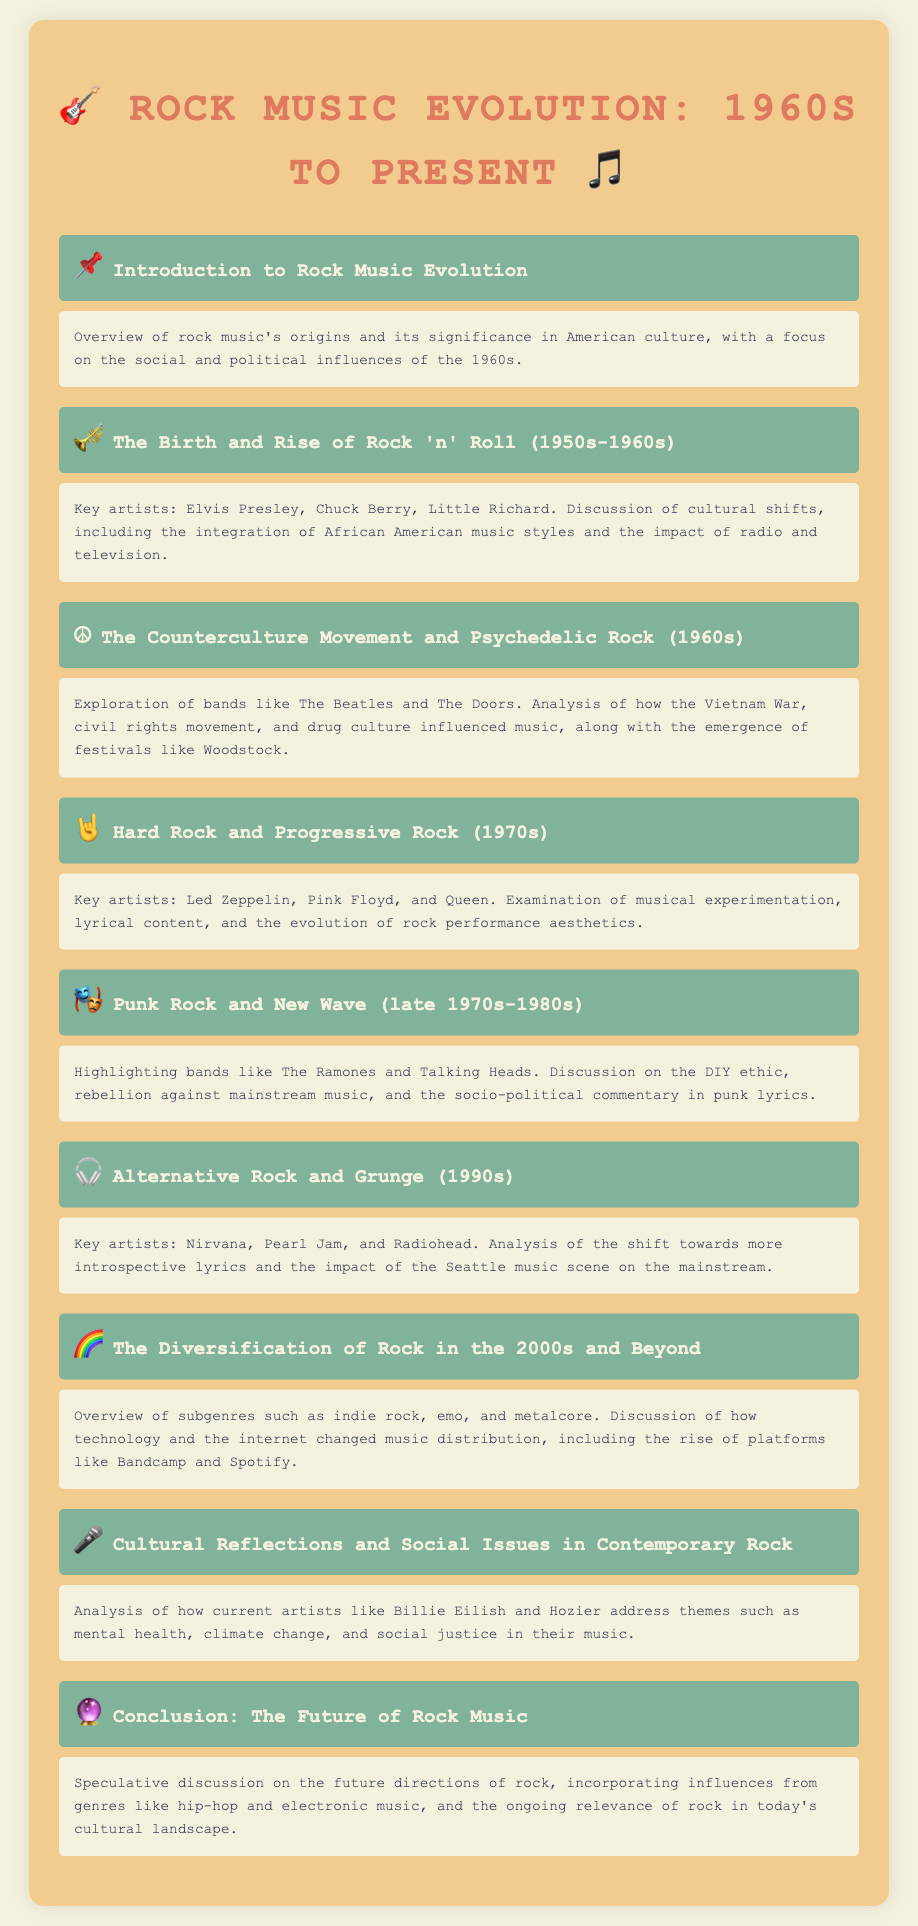what genre influenced the creation of rock music? Rock music was significantly influenced by African American music styles, as mentioned in the document.
Answer: African American music styles who is noted as a key artist in punk rock? The document highlights The Ramones as a key artist during the punk rock era.
Answer: The Ramones what significant cultural event is associated with the 1960s and rock music? The document mentions the Vietnam War as a key cultural event influencing rock music during the 1960s.
Answer: Vietnam War which band is associated with hard rock in the 1970s? Led Zeppelin is noted as a key artist within the hard rock genre in the 1970s.
Answer: Led Zeppelin what change did the Seattle music scene bring in the 1990s? The document states that the Seattle music scene impacted the mainstream leading to more introspective lyrics.
Answer: Introspective lyrics what has changed in music distribution in the 2000s? The document indicates that technology and the internet transformed music distribution, highlighting platforms like Bandcamp and Spotify.
Answer: Bandcamp and Spotify which contemporary artists address social issues in their music? The document mentions Billie Eilish and Hozier as current artists discussing themes like climate change and social justice.
Answer: Billie Eilish and Hozier what was a significant aspect of the cultural shifts during the 1960s? The document discusses the emergence of festivals like Woodstock as a key cultural shift in the 1960s.
Answer: Woodstock what is a characteristic of alternative rock in the 1990s? The document notes that alternative rock featured more introspective lyrics, particularly in the 1990s.
Answer: Introspective lyrics 